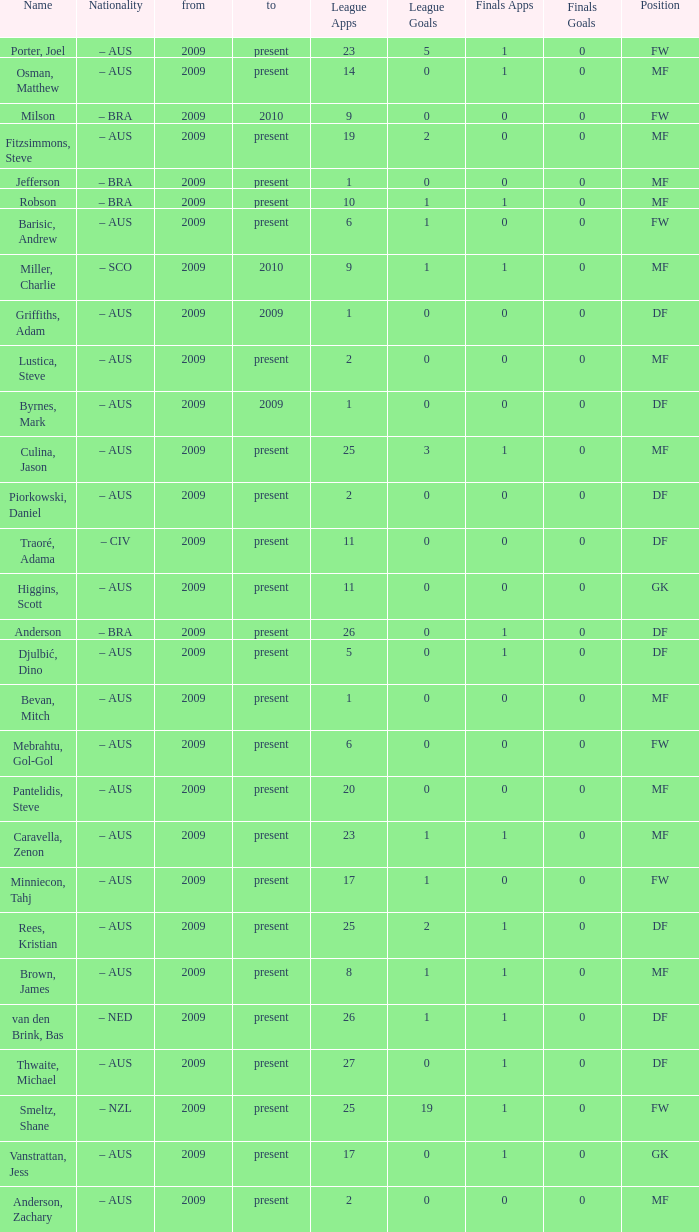Name the mosst finals apps 1.0. 